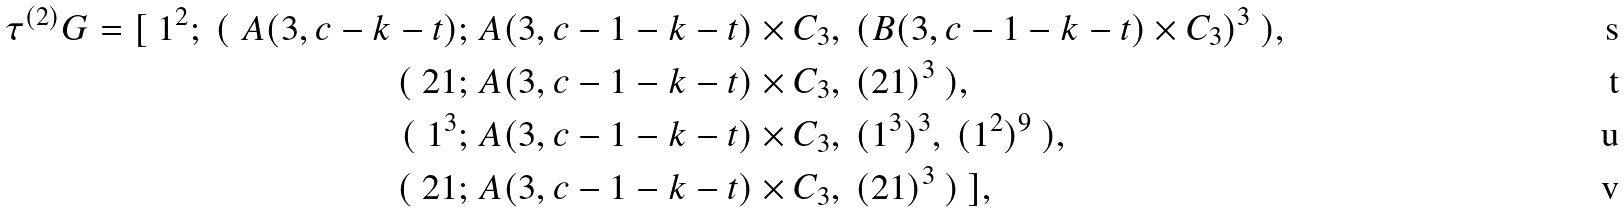<formula> <loc_0><loc_0><loc_500><loc_500>\tau ^ { ( 2 ) } { G } = [ \ 1 ^ { 2 } ; \ ( \ A ( 3 , c - k - t ) ; \ & A ( 3 , c - 1 - k - t ) \times C _ { 3 } , \ ( B ( 3 , c - 1 - k - t ) \times C _ { 3 } ) ^ { 3 } \ ) , \\ ( \ 2 1 ; \ & A ( 3 , c - 1 - k - t ) \times C _ { 3 } , \ ( 2 1 ) ^ { 3 } \ ) , \\ ( \ 1 ^ { 3 } ; \ & A ( 3 , c - 1 - k - t ) \times C _ { 3 } , \ ( 1 ^ { 3 } ) ^ { 3 } , \ ( 1 ^ { 2 } ) ^ { 9 } \ ) , \\ ( \ 2 1 ; \ & A ( 3 , c - 1 - k - t ) \times C _ { 3 } , \ ( 2 1 ) ^ { 3 } \ ) \ ] ,</formula> 